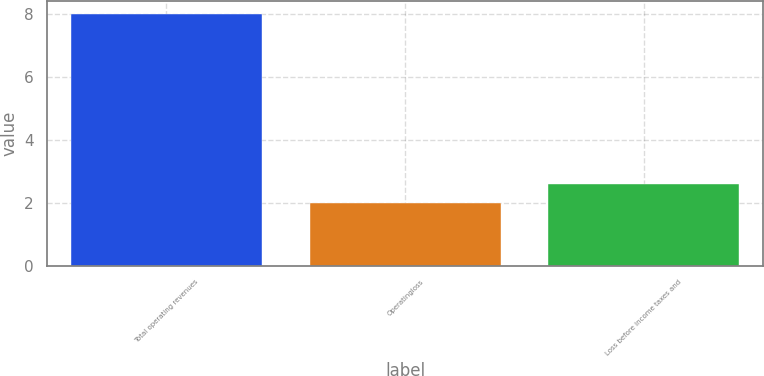Convert chart. <chart><loc_0><loc_0><loc_500><loc_500><bar_chart><fcel>Total operating revenues<fcel>Operatingloss<fcel>Loss before income taxes and<nl><fcel>8<fcel>2<fcel>2.6<nl></chart> 